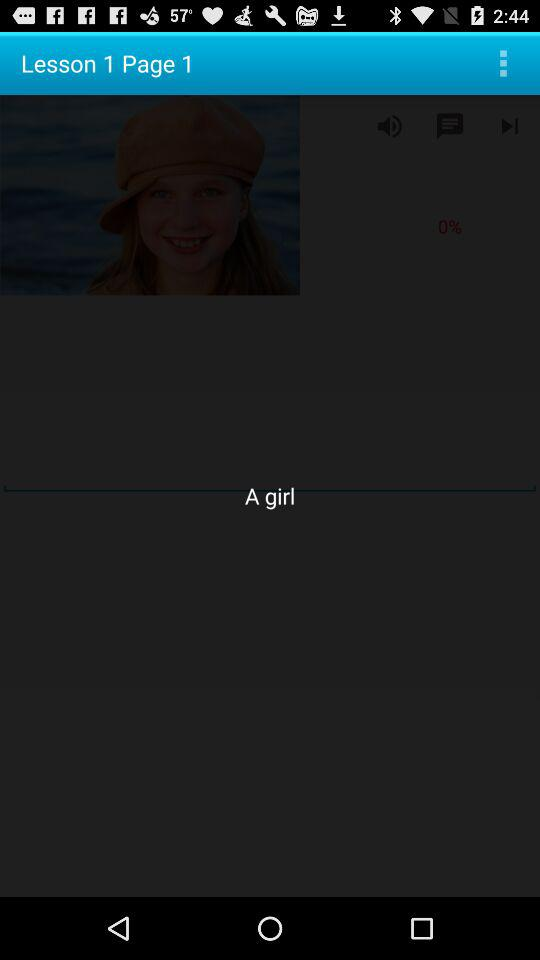What is the current page number shown on the screen? The current page number is 1. 